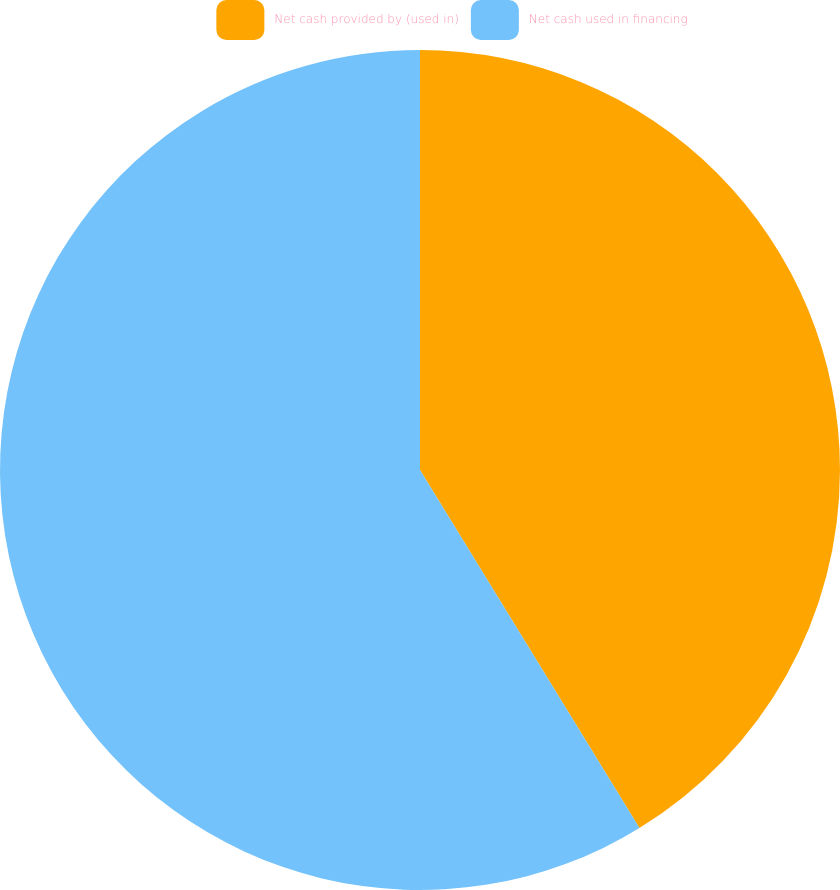<chart> <loc_0><loc_0><loc_500><loc_500><pie_chart><fcel>Net cash provided by (used in)<fcel>Net cash used in financing<nl><fcel>41.25%<fcel>58.75%<nl></chart> 